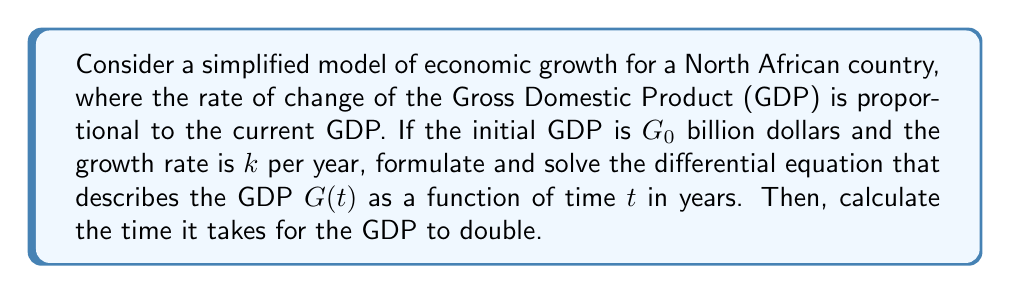Give your solution to this math problem. 1) First, we need to formulate the differential equation. The rate of change of GDP is proportional to the current GDP, which can be expressed as:

   $$\frac{dG}{dt} = kG$$

   where $G$ is the GDP and $k$ is the growth rate constant.

2) This is a first-order linear differential equation. We can solve it using separation of variables:

   $$\frac{dG}{G} = k dt$$

3) Integrating both sides:

   $$\int \frac{dG}{G} = \int k dt$$

   $$\ln|G| = kt + C$$

   where $C$ is the constant of integration.

4) Taking the exponential of both sides:

   $$G = e^{kt + C} = e^C \cdot e^{kt}$$

5) At $t = 0$, $G = G_0$. So:

   $$G_0 = e^C \cdot e^{k \cdot 0} = e^C$$

6) Therefore, the general solution is:

   $$G(t) = G_0 e^{kt}$$

7) To find the time it takes for the GDP to double, we set $G(t) = 2G_0$:

   $$2G_0 = G_0 e^{kt}$$

   $$2 = e^{kt}$$

8) Taking the natural logarithm of both sides:

   $$\ln 2 = kt$$

9) Solving for $t$:

   $$t = \frac{\ln 2}{k}$$

This is the time it takes for the GDP to double.
Answer: The differential equation describing the GDP growth is:

$$\frac{dG}{dt} = kG$$

The solution to this equation is:

$$G(t) = G_0 e^{kt}$$

The time it takes for the GDP to double is:

$$t = \frac{\ln 2}{k}$$ 